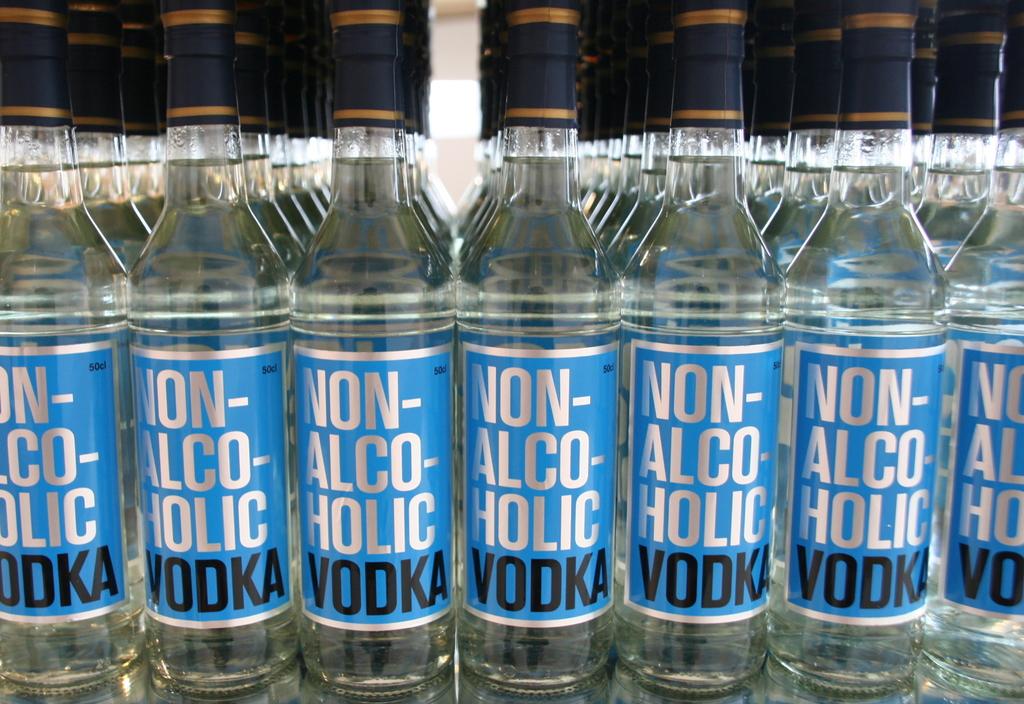How much alcohol does the vodka have?
Your answer should be compact. None. What type of vodka is this?
Your response must be concise. Non-alcoholic. 